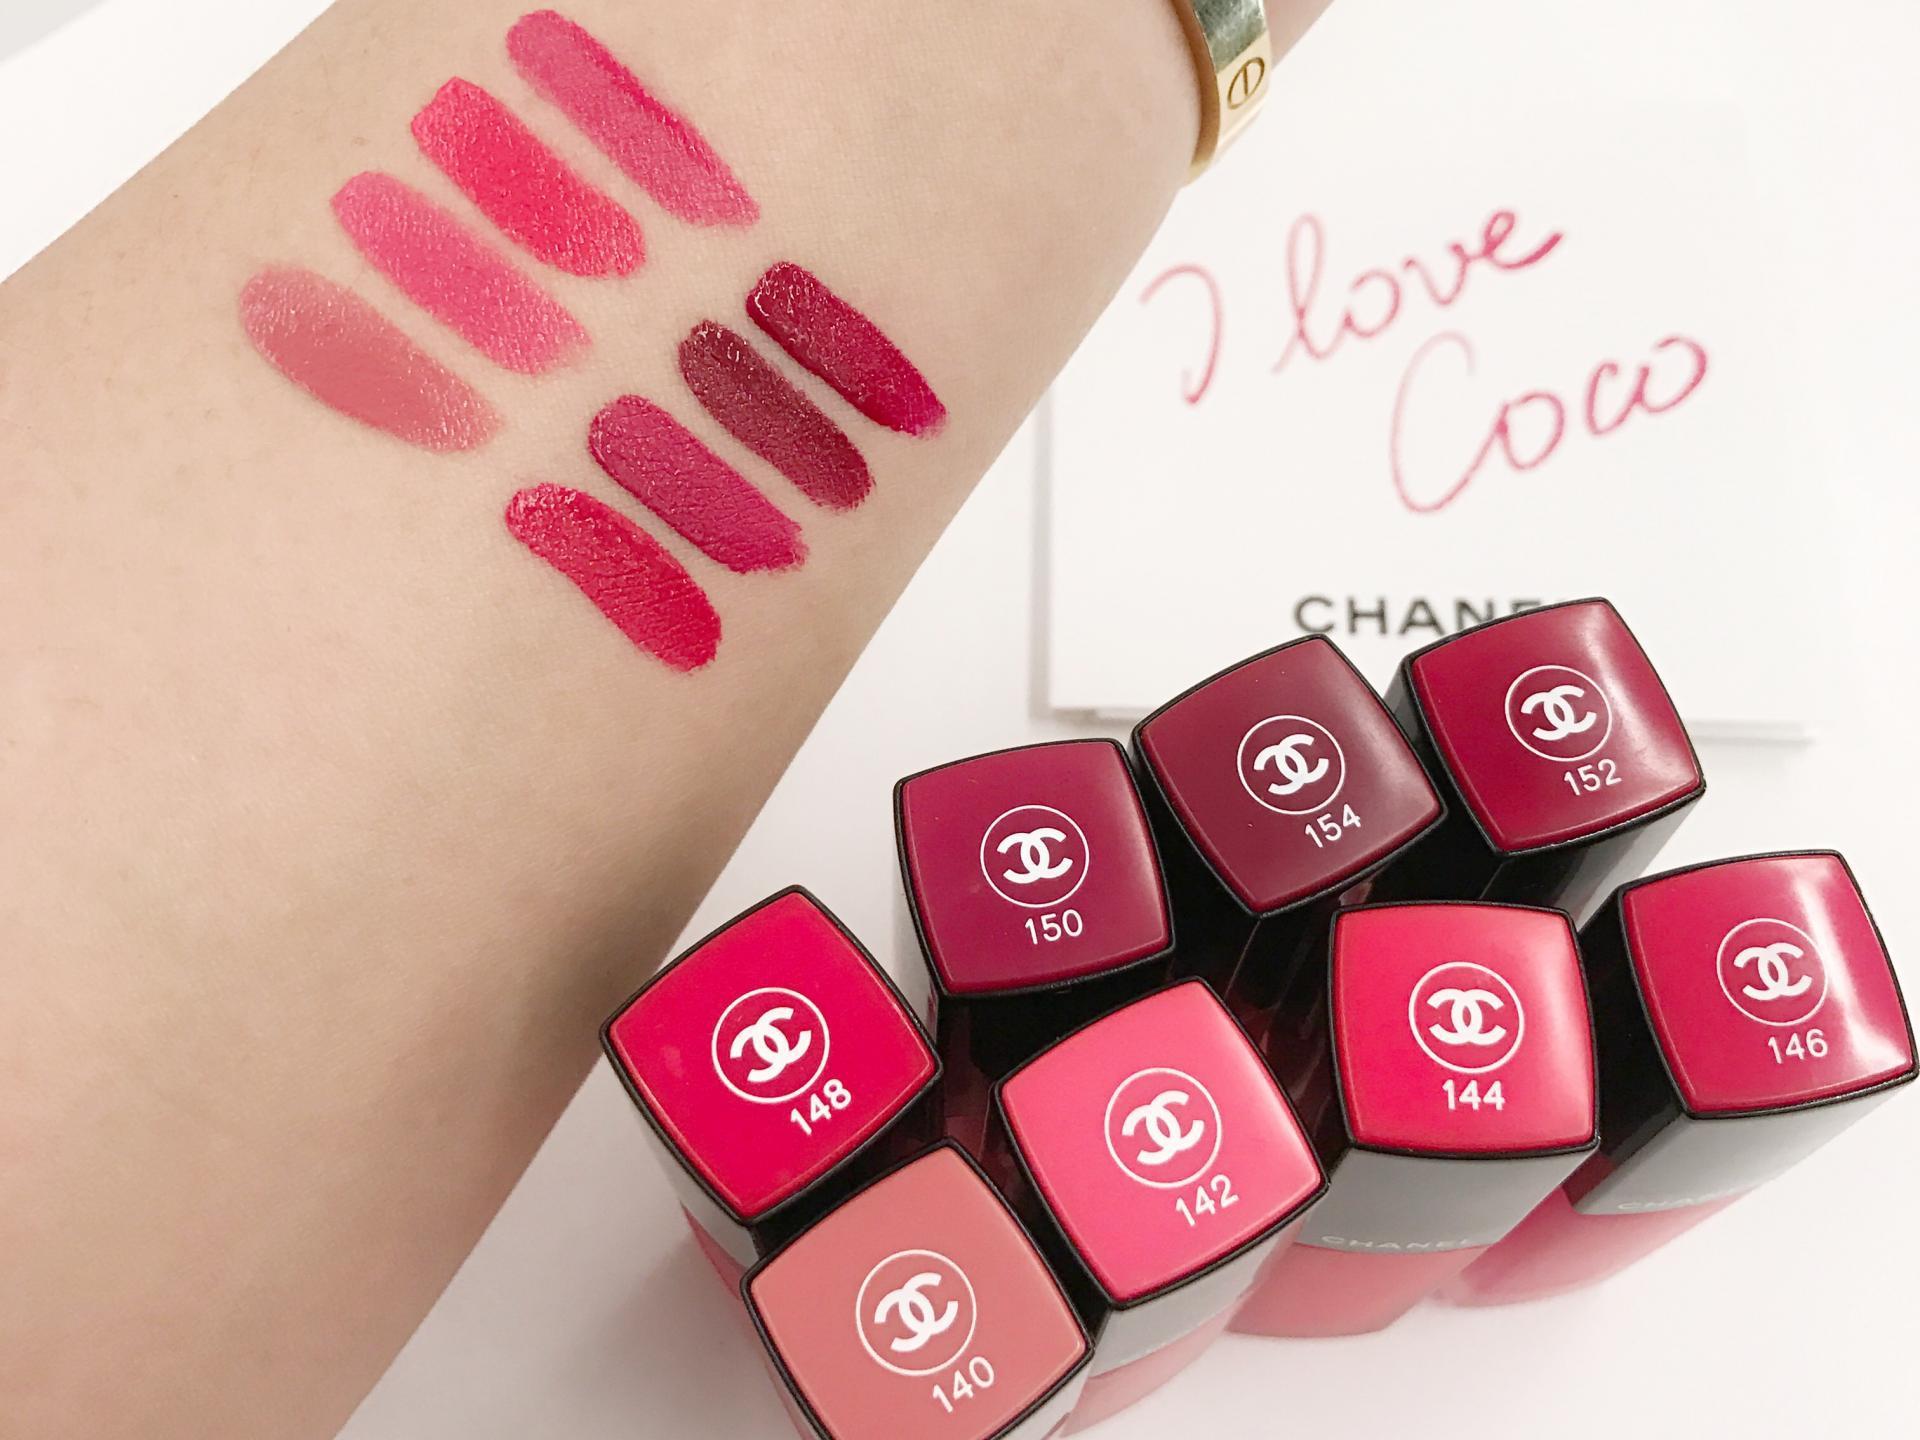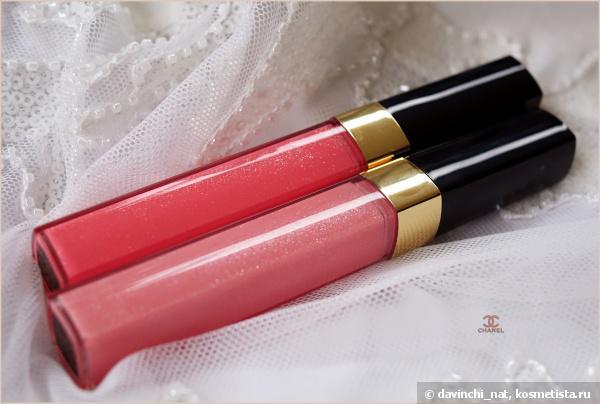The first image is the image on the left, the second image is the image on the right. Considering the images on both sides, is "The left image shows a lipstick color test on a person's wrist area." valid? Answer yes or no. Yes. 